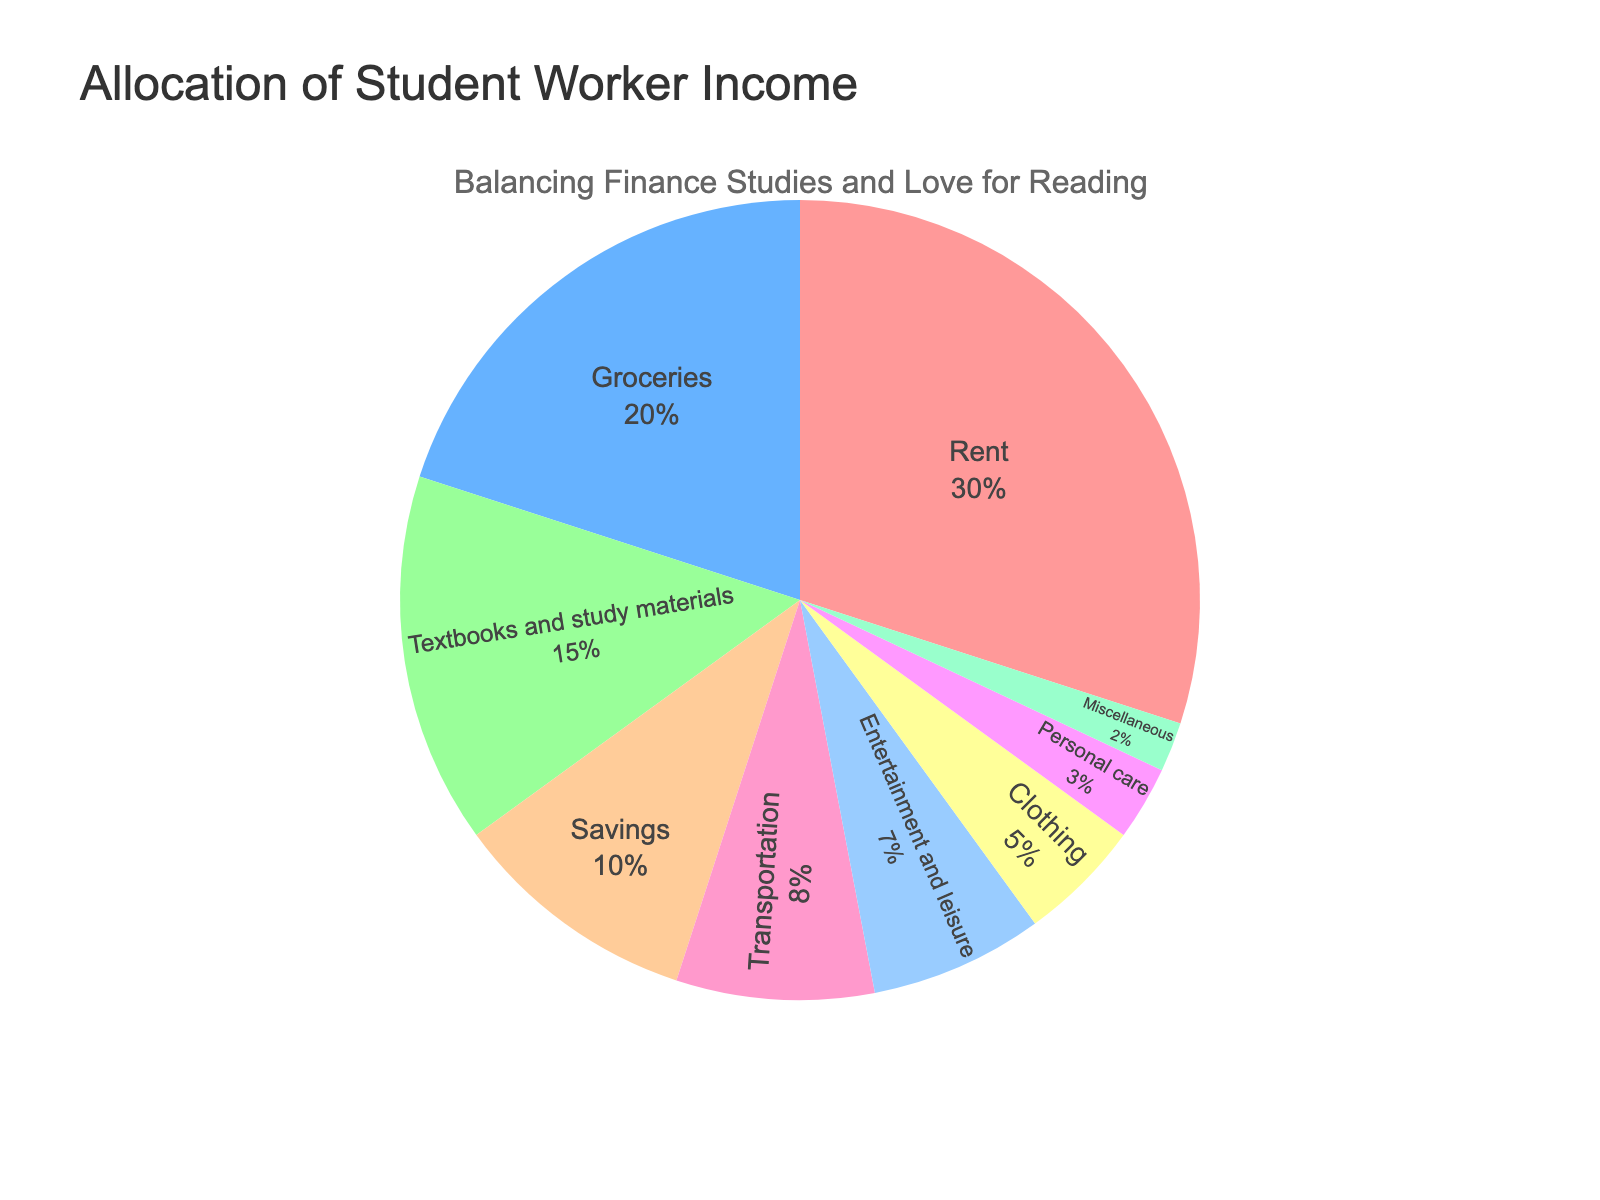Which category has the largest allocation of income? The category with the largest allocation is the one with the highest percentage slice in the pie chart. This is visually the biggest slice.
Answer: Rent What is the total percentage allocated to Groceries and Savings combined? Add the percentage allocated to Groceries (20%) and Savings (10%). The total is 20 + 10 = 30.
Answer: 30% Which is allocated a higher percentage: Transportation or Entertainment and leisure? Compare the percentages for Transportation (8%) and Entertainment and leisure (7%). Transportation has a higher percentage.
Answer: Transportation How much more is allocated to Rent compared to Textbooks and study materials? Subtract the percentage for Textbooks and study materials (15%) from Rent (30%). The difference is 30 - 15 = 15.
Answer: 15% What is the total percentage allocated to categories other than Rent and Groceries? Subtract the combined percentage of Rent (30%) and Groceries (20%) from 100%. Total is 100 - (30 + 20) = 50.
Answer: 50% What percentage of the income is allocated to categories that each receive less than 10%? Sum the percentages for categories under 10%: Transportation (8%), Savings (10%), Entertainment and leisure (7%), Clothing (5%), Personal care (3%), and Miscellaneous (2%). The total is 8 + 10 + 7 + 5 + 3 + 2 = 35%.
Answer: 35% Which category has the smallest allocation of income? The smallest allocation is the category with the smallest percentage slice in the pie chart. This is visually the smallest slice.
Answer: Miscellaneous What is the combined allocation for Transportation and Personal care compared to Groceries? Add percentages for Transportation (8%) and Personal care (3%). Combined, they are 8 + 3 = 11%. Compare to Groceries (20%). Groceries has a higher percentage.
Answer: Groceries is higher How does the allocation for Entertainment and leisure compare visually to Textbooks and study materials? Visually observe that the slice for Entertainment and leisure is smaller than the slice for Textbooks and study materials.
Answer: Smaller What fraction of the income is allocated to Clothing and Miscellaneous combined? Add percentages for Clothing (5%) and Miscellaneous (2%). Combined is 5 + 2 = 7%. The fraction is 7%.
Answer: 7% 